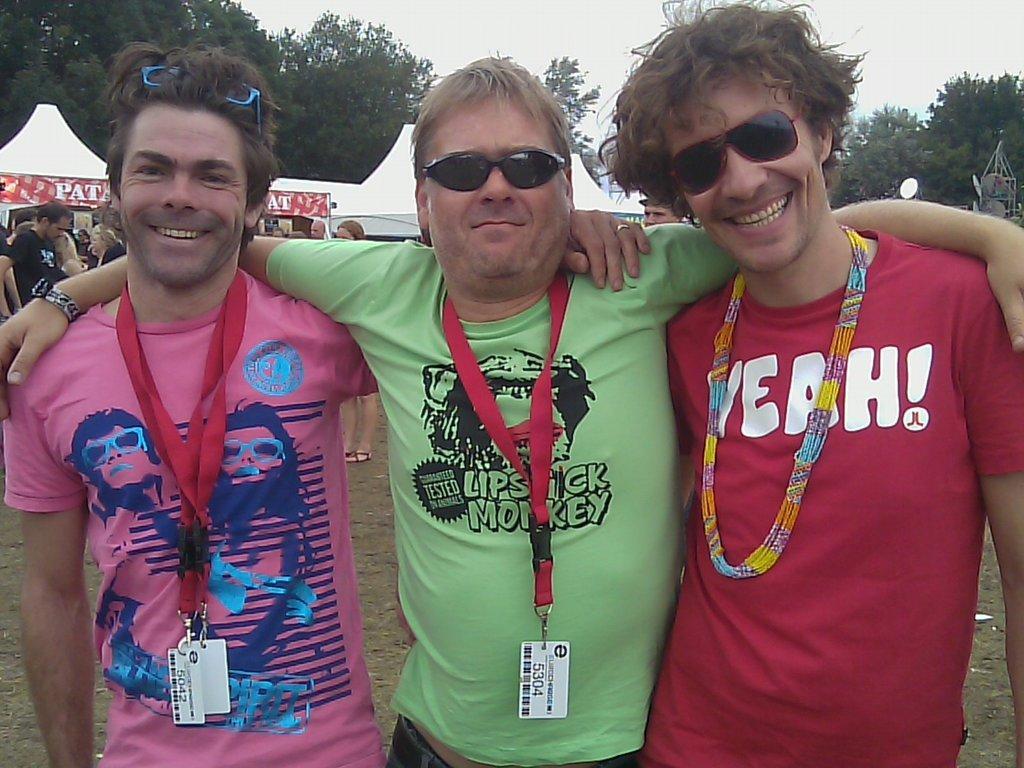Could you give a brief overview of what you see in this image? In front of the image there are three people having a smile on their faces. Behind them there are a few other people standing. In the background of the image there are tents, trees and a few other objects. At the top of the image there is sky. 